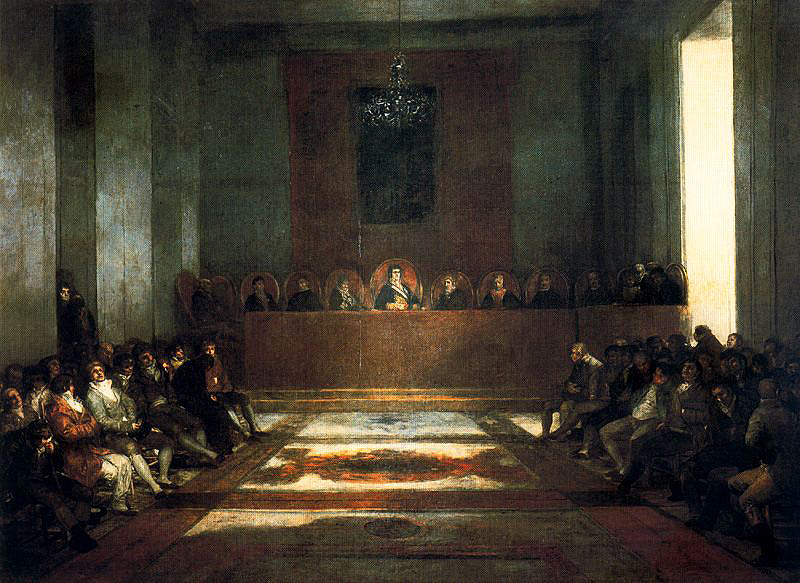What might the various expressions and postures of the attendees tell us about the nature of the event? The varied expressions and postures of the attendees, ranging from solemn and bowed heads to attentive and upright, suggest a moment of significant emotional or spiritual engagement. This diverse depiction indicates the impact of the proceedings on the individuals present, perhaps during a moment of collective reflection, prayer, or hearing poignant teachings or decrees. 